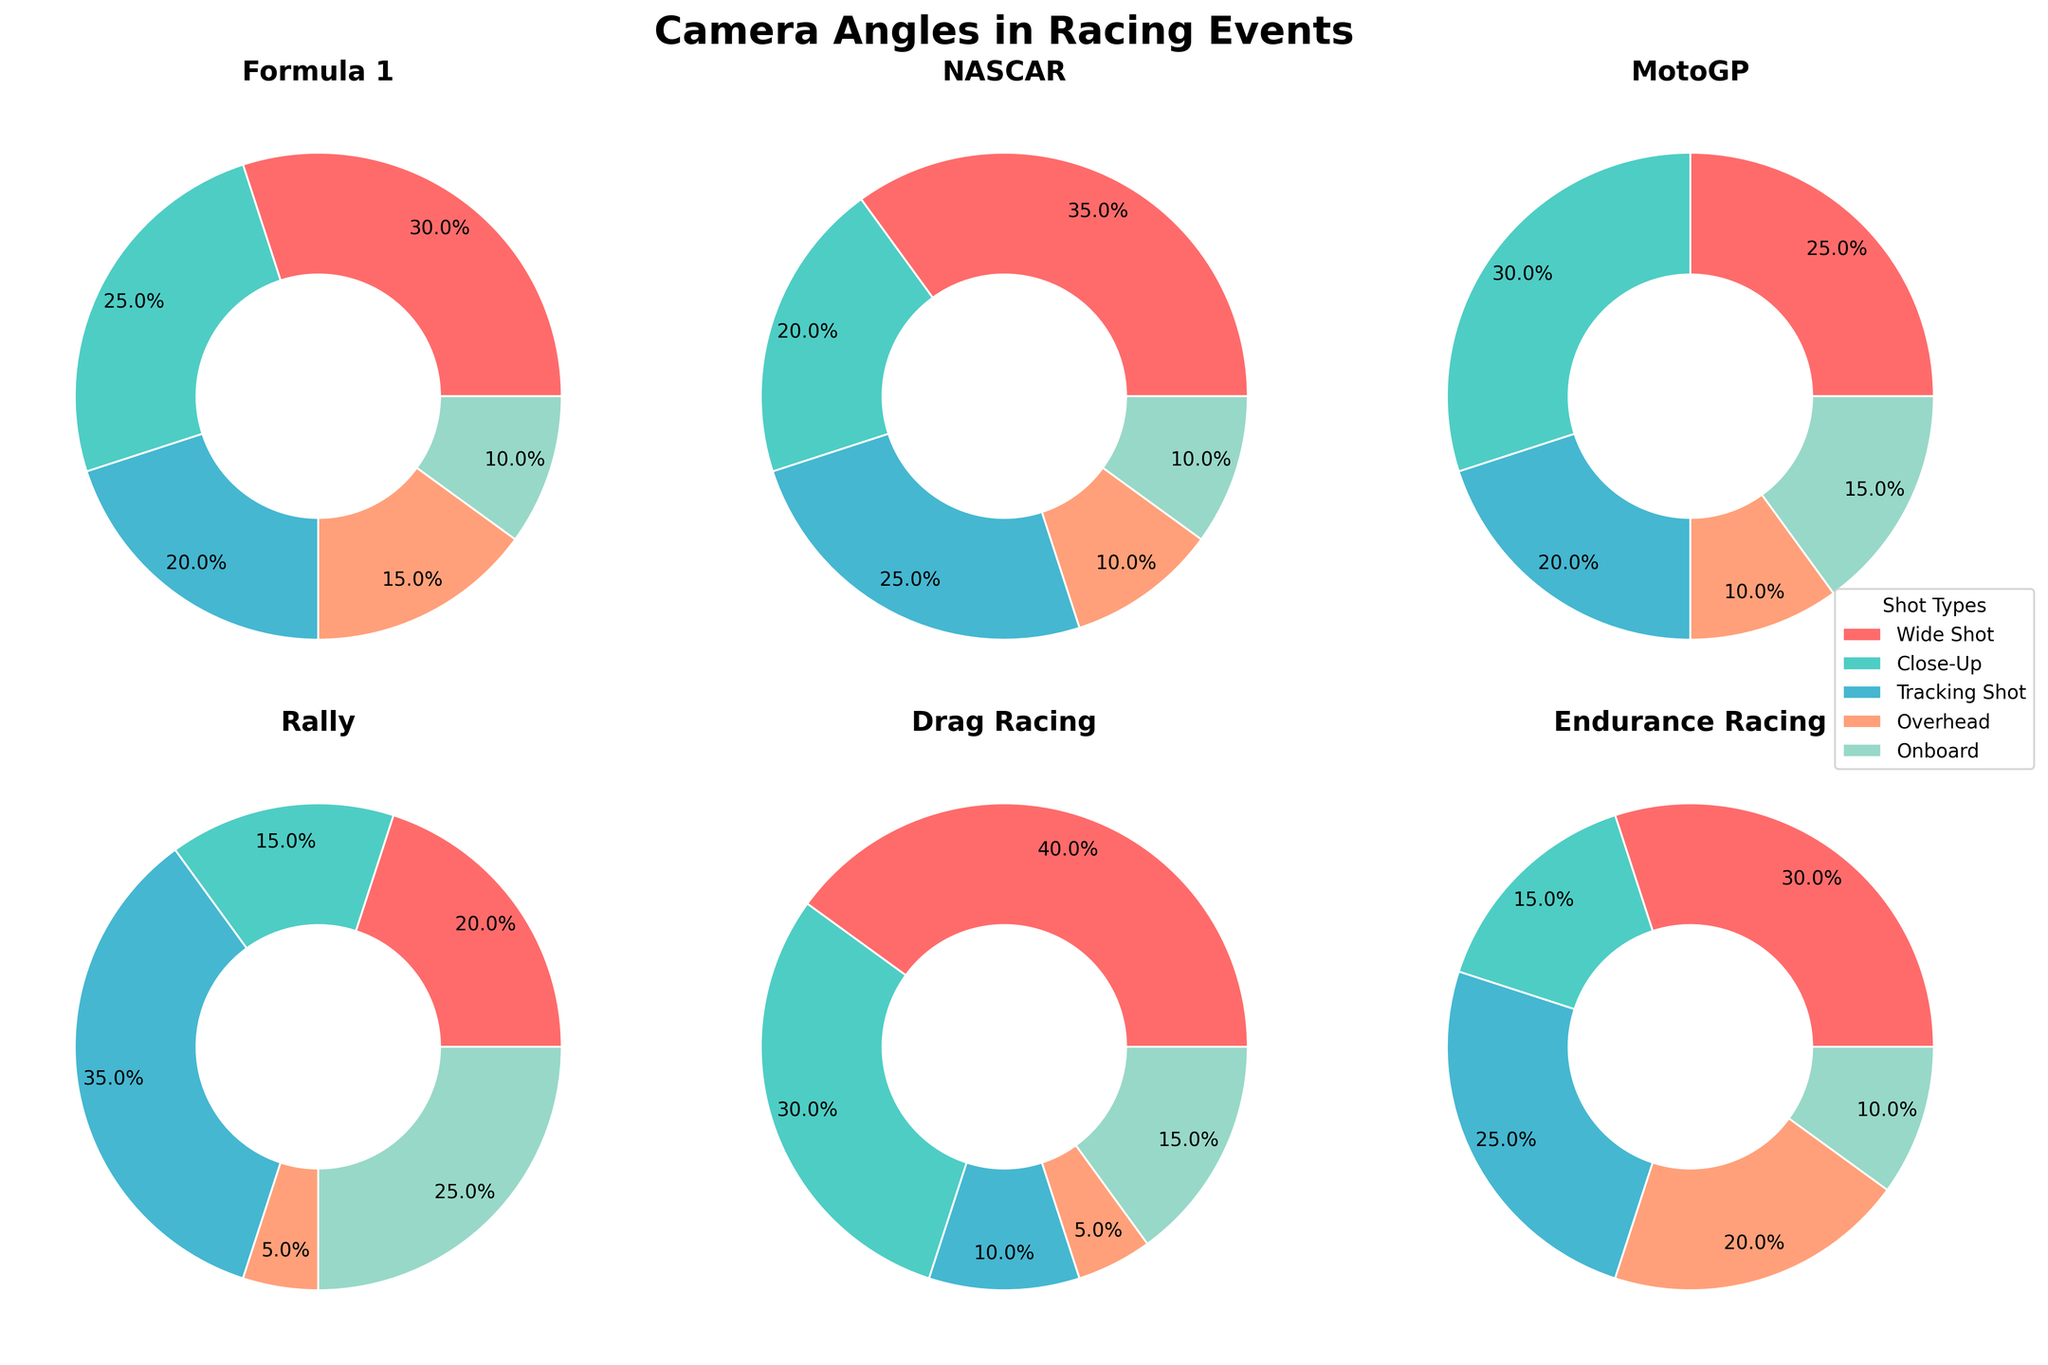Which event has the highest percentage of wide shots? By observing each pie chart, the segment representing wide shots should be compared across all events. Formula 1 and Endurance Racing events each use 30%, while Drag Racing uses 40%.
Answer: Drag Racing What is the proportion of close-up shots used in MotoGP? By inspecting the MotoGP pie chart, locate the segment for close-up shots and read the percentage value. The close-up segment is 30%.
Answer: 30% How many total events have onboard shots greater than or equal to 15%? By examining each pie chart, identify segments where the onboard shots are 15% or more. Formula 1 (10%), NASCAR (10%), MotoGP (15%), Rally (25%), Drag Racing (15%), and Endurance Racing (10%). Only MotoGP, Rally, and Drag Racing satisfy the condition.
Answer: 3 Based on the data, which event uses tracking shots the least? Check all subplots to find the event with the smallest segment for tracking shots. Rally has the least tracking shots at 5%.
Answer: Rally Which two events have an equal percentage of onboard shots? Compare the onboard shot segments across all events and identify those with the same percentage values. Formula 1 and NASCAR both have onboard shots at 10%.
Answer: Formula 1 and NASCAR What is the combined percentage of overhead shots for Formula 1 and Rally events? Sum the percentage values for overhead shots from the Formula 1 (15%) and Rally (5%) pie charts.
Answer: 20% Which event uses the highest proportion of tracking shots? Identify the pie chart where the segment for tracking shots is the largest. Rally uses 35%, which is the highest.
Answer: Rally Are the close-up shot percentages for Endurance Racing higher or lower than those for NASCAR? Compare the close-up shot segments: Endurance Racing has 15%, while NASCAR has 20%. Endurance Racing's proportion is lower.
Answer: Lower 